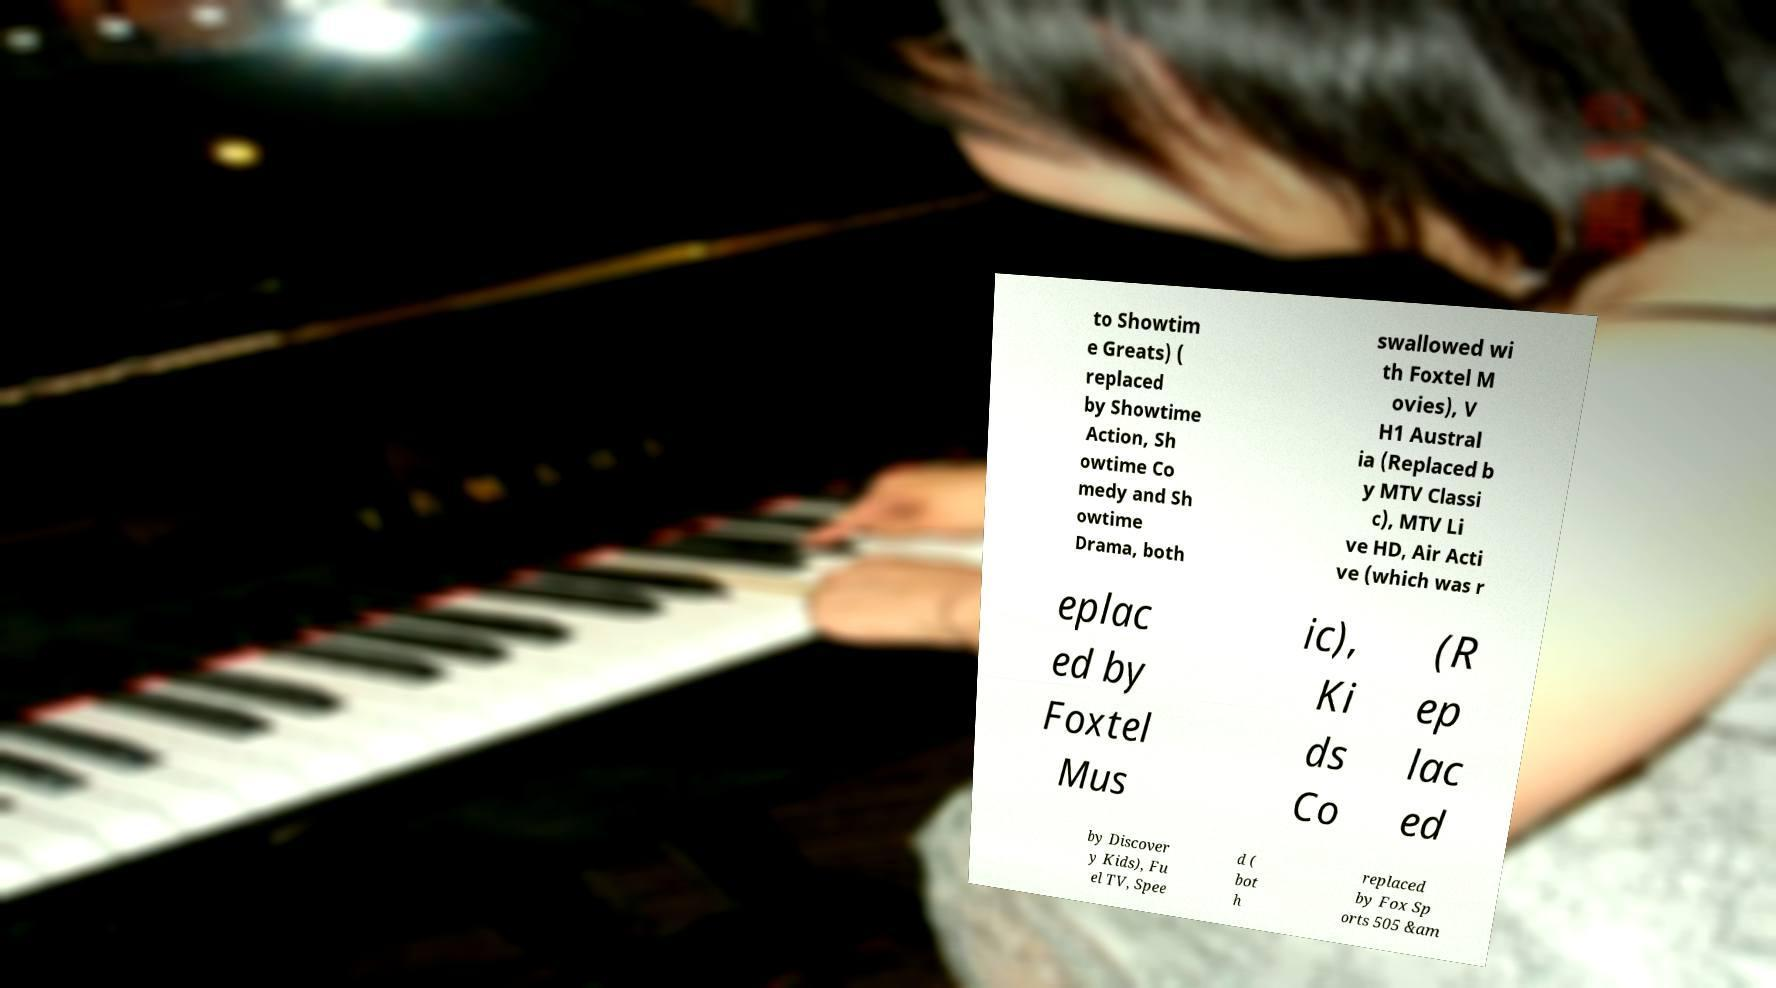Can you accurately transcribe the text from the provided image for me? to Showtim e Greats) ( replaced by Showtime Action, Sh owtime Co medy and Sh owtime Drama, both swallowed wi th Foxtel M ovies), V H1 Austral ia (Replaced b y MTV Classi c), MTV Li ve HD, Air Acti ve (which was r eplac ed by Foxtel Mus ic), Ki ds Co (R ep lac ed by Discover y Kids), Fu el TV, Spee d ( bot h replaced by Fox Sp orts 505 &am 